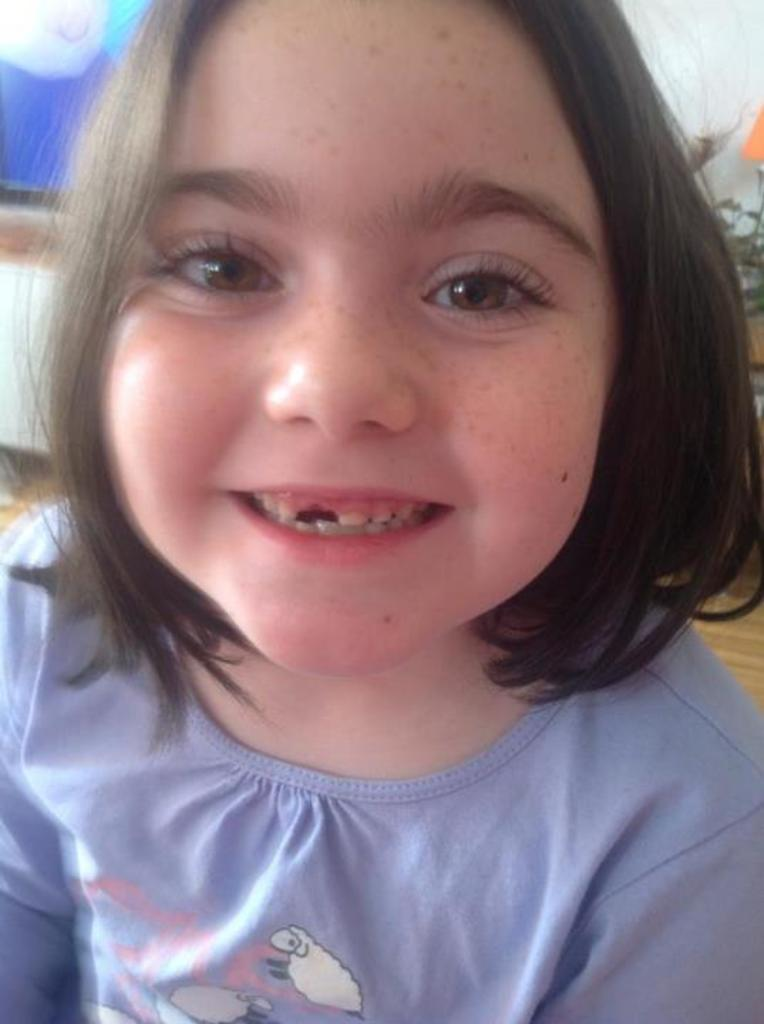Who is the main subject in the picture? There is a girl in the picture. What is the girl's expression in the picture? The girl is smiling in the picture. What can be seen in the background of the picture? There are objects visible in the background of the picture. What type of toe print can be seen on the girl's forehead in the image? There is no toe print visible on the girl's forehead in the image. What discovery was made by the girl in the image? The provided facts do not mention any discovery made by the girl in the image. 